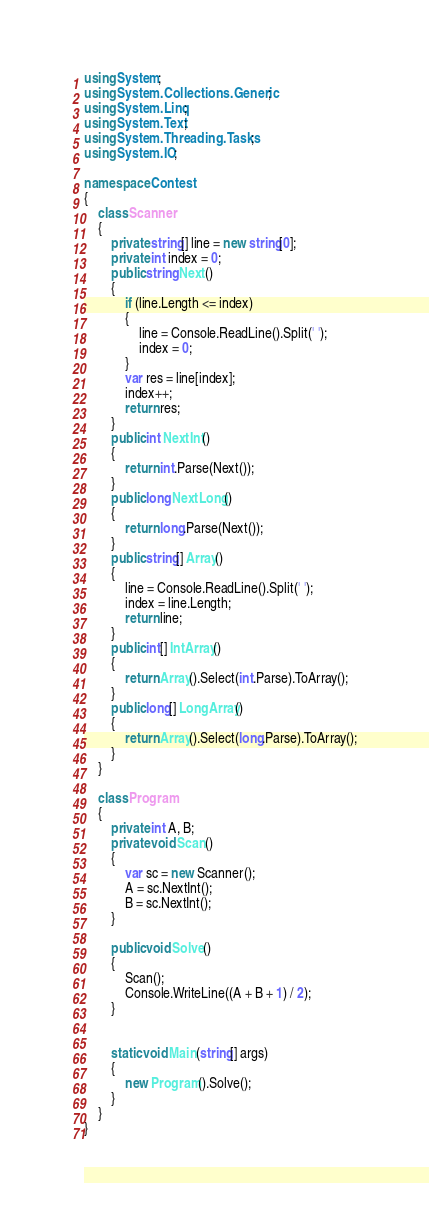Convert code to text. <code><loc_0><loc_0><loc_500><loc_500><_C#_>using System;
using System.Collections.Generic;
using System.Linq;
using System.Text;
using System.Threading.Tasks;
using System.IO;

namespace Contest
{
    class Scanner
    {
        private string[] line = new string[0];
        private int index = 0;
        public string Next()
        {
            if (line.Length <= index)
            {
                line = Console.ReadLine().Split(' ');
                index = 0;
            }
            var res = line[index];
            index++;
            return res;
        }
        public int NextInt()
        {
            return int.Parse(Next());
        }
        public long NextLong()
        {
            return long.Parse(Next());
        }
        public string[] Array()
        {
            line = Console.ReadLine().Split(' ');
            index = line.Length;
            return line;
        }
        public int[] IntArray()
        {
            return Array().Select(int.Parse).ToArray();
        }
        public long[] LongArray()
        {
            return Array().Select(long.Parse).ToArray();
        }
    }

    class Program
    {
        private int A, B;
        private void Scan()
        {
            var sc = new Scanner();
            A = sc.NextInt();
            B = sc.NextInt();
        }

        public void Solve()
        {
            Scan();
            Console.WriteLine((A + B + 1) / 2);
        }


        static void Main(string[] args)
        {
            new Program().Solve();
        }
    }
}</code> 